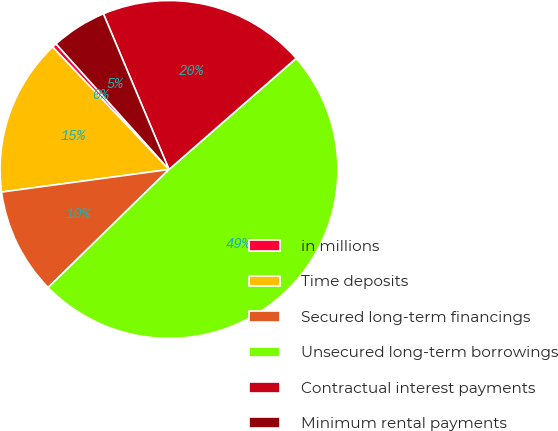<chart> <loc_0><loc_0><loc_500><loc_500><pie_chart><fcel>in millions<fcel>Time deposits<fcel>Secured long-term financings<fcel>Unsecured long-term borrowings<fcel>Contractual interest payments<fcel>Minimum rental payments<nl><fcel>0.44%<fcel>15.04%<fcel>10.18%<fcel>49.12%<fcel>19.91%<fcel>5.31%<nl></chart> 